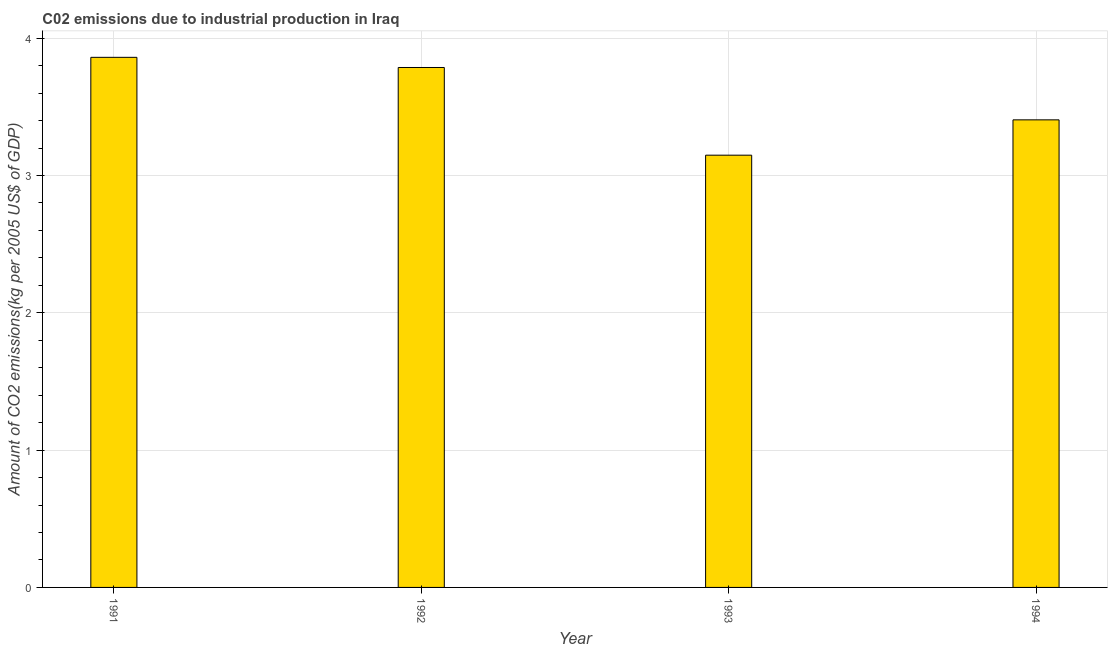Does the graph contain grids?
Ensure brevity in your answer.  Yes. What is the title of the graph?
Your answer should be compact. C02 emissions due to industrial production in Iraq. What is the label or title of the X-axis?
Make the answer very short. Year. What is the label or title of the Y-axis?
Provide a succinct answer. Amount of CO2 emissions(kg per 2005 US$ of GDP). What is the amount of co2 emissions in 1993?
Your response must be concise. 3.15. Across all years, what is the maximum amount of co2 emissions?
Make the answer very short. 3.86. Across all years, what is the minimum amount of co2 emissions?
Offer a terse response. 3.15. In which year was the amount of co2 emissions maximum?
Your answer should be very brief. 1991. What is the sum of the amount of co2 emissions?
Your answer should be very brief. 14.2. What is the difference between the amount of co2 emissions in 1991 and 1994?
Your response must be concise. 0.46. What is the average amount of co2 emissions per year?
Offer a terse response. 3.55. What is the median amount of co2 emissions?
Your response must be concise. 3.6. In how many years, is the amount of co2 emissions greater than 0.2 kg per 2005 US$ of GDP?
Give a very brief answer. 4. What is the ratio of the amount of co2 emissions in 1992 to that in 1994?
Offer a very short reply. 1.11. Is the amount of co2 emissions in 1993 less than that in 1994?
Make the answer very short. Yes. Is the difference between the amount of co2 emissions in 1993 and 1994 greater than the difference between any two years?
Keep it short and to the point. No. What is the difference between the highest and the second highest amount of co2 emissions?
Your answer should be compact. 0.07. What is the difference between the highest and the lowest amount of co2 emissions?
Provide a succinct answer. 0.71. In how many years, is the amount of co2 emissions greater than the average amount of co2 emissions taken over all years?
Offer a very short reply. 2. How many bars are there?
Give a very brief answer. 4. What is the difference between two consecutive major ticks on the Y-axis?
Your answer should be very brief. 1. Are the values on the major ticks of Y-axis written in scientific E-notation?
Make the answer very short. No. What is the Amount of CO2 emissions(kg per 2005 US$ of GDP) of 1991?
Provide a short and direct response. 3.86. What is the Amount of CO2 emissions(kg per 2005 US$ of GDP) in 1992?
Offer a terse response. 3.79. What is the Amount of CO2 emissions(kg per 2005 US$ of GDP) in 1993?
Provide a short and direct response. 3.15. What is the Amount of CO2 emissions(kg per 2005 US$ of GDP) of 1994?
Your answer should be compact. 3.4. What is the difference between the Amount of CO2 emissions(kg per 2005 US$ of GDP) in 1991 and 1992?
Your answer should be compact. 0.07. What is the difference between the Amount of CO2 emissions(kg per 2005 US$ of GDP) in 1991 and 1993?
Your response must be concise. 0.71. What is the difference between the Amount of CO2 emissions(kg per 2005 US$ of GDP) in 1991 and 1994?
Your response must be concise. 0.46. What is the difference between the Amount of CO2 emissions(kg per 2005 US$ of GDP) in 1992 and 1993?
Your answer should be very brief. 0.64. What is the difference between the Amount of CO2 emissions(kg per 2005 US$ of GDP) in 1992 and 1994?
Your answer should be very brief. 0.38. What is the difference between the Amount of CO2 emissions(kg per 2005 US$ of GDP) in 1993 and 1994?
Your answer should be very brief. -0.26. What is the ratio of the Amount of CO2 emissions(kg per 2005 US$ of GDP) in 1991 to that in 1992?
Make the answer very short. 1.02. What is the ratio of the Amount of CO2 emissions(kg per 2005 US$ of GDP) in 1991 to that in 1993?
Make the answer very short. 1.23. What is the ratio of the Amount of CO2 emissions(kg per 2005 US$ of GDP) in 1991 to that in 1994?
Offer a very short reply. 1.13. What is the ratio of the Amount of CO2 emissions(kg per 2005 US$ of GDP) in 1992 to that in 1993?
Your response must be concise. 1.2. What is the ratio of the Amount of CO2 emissions(kg per 2005 US$ of GDP) in 1992 to that in 1994?
Your answer should be very brief. 1.11. What is the ratio of the Amount of CO2 emissions(kg per 2005 US$ of GDP) in 1993 to that in 1994?
Your answer should be compact. 0.92. 